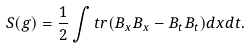<formula> <loc_0><loc_0><loc_500><loc_500>S ( g ) = \frac { 1 } { 2 } \int t r ( B _ { x } B _ { x } - B _ { t } B _ { t } ) d x d t .</formula> 